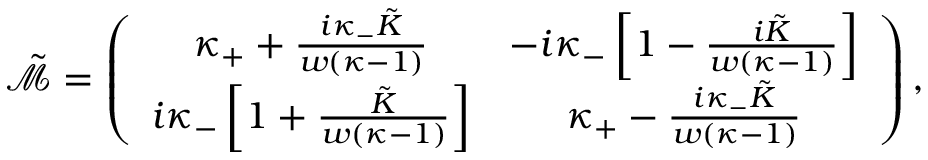<formula> <loc_0><loc_0><loc_500><loc_500>\tilde { \mathcal { M } } = \left ( \begin{array} { c c } { \kappa _ { + } + \frac { i \kappa _ { - } \tilde { K } } { w ( \kappa - 1 ) } } & { - i \kappa _ { - } \left [ 1 - \frac { i \tilde { K } } { w ( \kappa - 1 ) } \right ] } \\ { i \kappa _ { - } \left [ 1 + \frac { \tilde { K } } { w ( \kappa - 1 ) } \right ] } & { \kappa _ { + } - \frac { i \kappa _ { - } \tilde { K } } { w ( \kappa - 1 ) } } \end{array} \right ) ,</formula> 